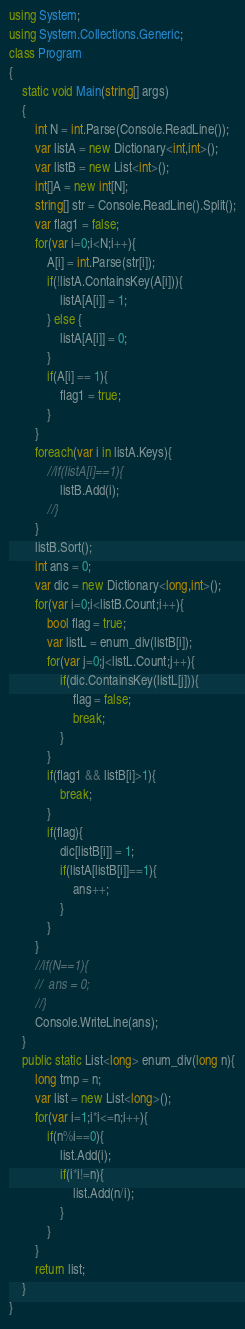<code> <loc_0><loc_0><loc_500><loc_500><_C#_>using System;
using System.Collections.Generic;
class Program
{
	static void Main(string[] args)
	{
		int N = int.Parse(Console.ReadLine());
		var listA = new Dictionary<int,int>();
		var listB = new List<int>();
		int[]A = new int[N];
		string[] str = Console.ReadLine().Split();
		var flag1 = false;
		for(var i=0;i<N;i++){
			A[i] = int.Parse(str[i]);
			if(!listA.ContainsKey(A[i])){
				listA[A[i]] = 1;
			} else {
				listA[A[i]] = 0;
			}
			if(A[i] == 1){
				flag1 = true;
			}
		}
		foreach(var i in listA.Keys){
			//if(listA[i]==1){
				listB.Add(i);
			//}
		}
		listB.Sort();
		int ans = 0;
		var dic = new Dictionary<long,int>();
		for(var i=0;i<listB.Count;i++){
			bool flag = true;
			var listL = enum_div(listB[i]);
			for(var j=0;j<listL.Count;j++){
				if(dic.ContainsKey(listL[j])){
					flag = false;
					break;
				}
			}
			if(flag1 && listB[i]>1){
				break;
			}
			if(flag){
				dic[listB[i]] = 1;
				if(listA[listB[i]]==1){
					ans++;
				}
			}
		}
		//if(N==1){
		//	ans = 0;
		//}
		Console.WriteLine(ans);
	}
	public static List<long> enum_div(long n){
		long tmp = n;
		var list = new List<long>();
		for(var i=1;i*i<=n;i++){
			if(n%i==0){
				list.Add(i);
				if(i*i!=n){
					list.Add(n/i);
				}
			}
		}
		return list;
	}
}</code> 